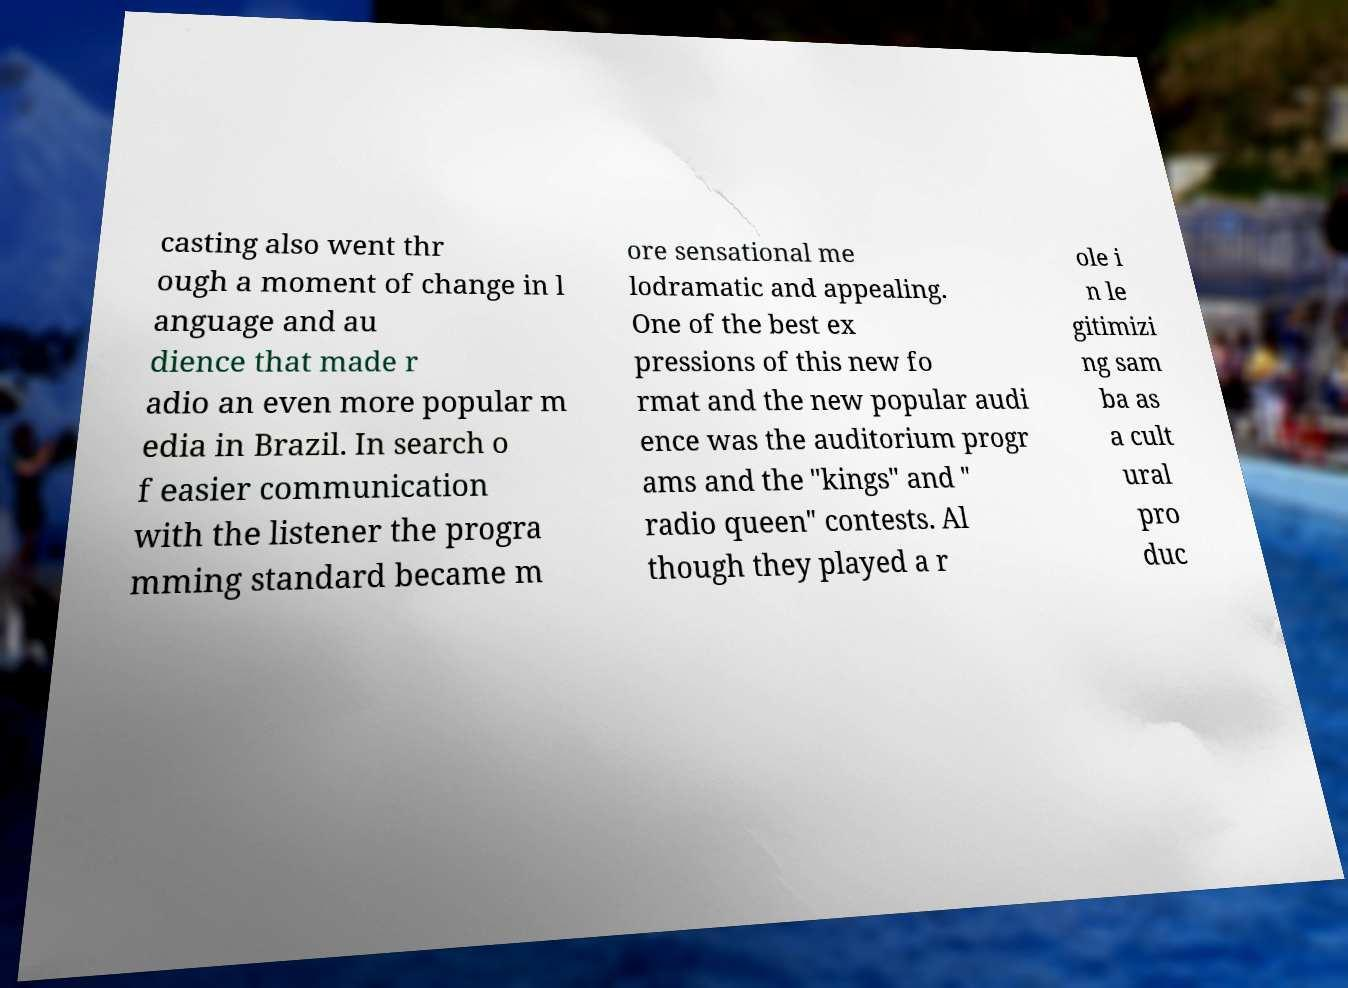I need the written content from this picture converted into text. Can you do that? casting also went thr ough a moment of change in l anguage and au dience that made r adio an even more popular m edia in Brazil. In search o f easier communication with the listener the progra mming standard became m ore sensational me lodramatic and appealing. One of the best ex pressions of this new fo rmat and the new popular audi ence was the auditorium progr ams and the "kings" and " radio queen" contests. Al though they played a r ole i n le gitimizi ng sam ba as a cult ural pro duc 